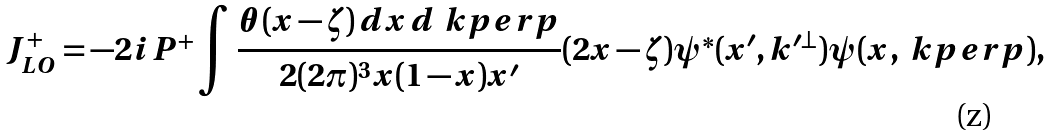Convert formula to latex. <formula><loc_0><loc_0><loc_500><loc_500>J ^ { + } _ { L O } = - 2 i P ^ { + } \int \frac { \theta ( x - \zeta ) \, d x \, d \ k p e r p } { 2 ( 2 \pi ) ^ { 3 } x ( 1 - x ) x ^ { \prime } } ( 2 x - \zeta ) \psi ^ { * } ( x ^ { \prime } , k ^ { \prime \perp } ) \psi ( x , \ k p e r p ) ,</formula> 